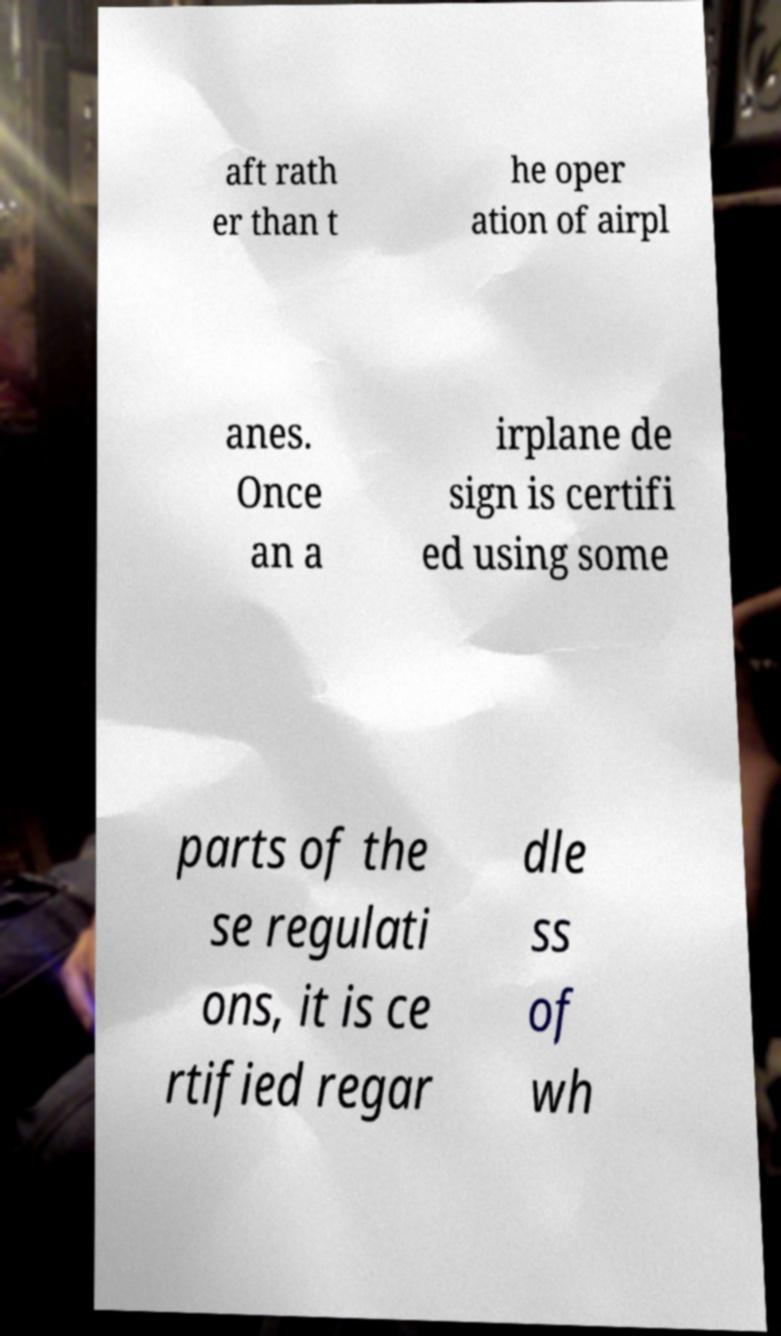Please identify and transcribe the text found in this image. aft rath er than t he oper ation of airpl anes. Once an a irplane de sign is certifi ed using some parts of the se regulati ons, it is ce rtified regar dle ss of wh 